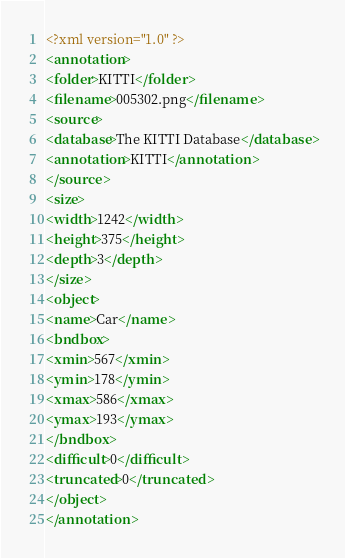<code> <loc_0><loc_0><loc_500><loc_500><_XML_><?xml version="1.0" ?>
<annotation>
<folder>KITTI</folder>
<filename>005302.png</filename>
<source>
<database>The KITTI Database</database>
<annotation>KITTI</annotation>
</source>
<size>
<width>1242</width>
<height>375</height>
<depth>3</depth>
</size>
<object>
<name>Car</name>
<bndbox>
<xmin>567</xmin>
<ymin>178</ymin>
<xmax>586</xmax>
<ymax>193</ymax>
</bndbox>
<difficult>0</difficult>
<truncated>0</truncated>
</object>
</annotation>
</code> 